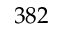<formula> <loc_0><loc_0><loc_500><loc_500>3 8 2</formula> 